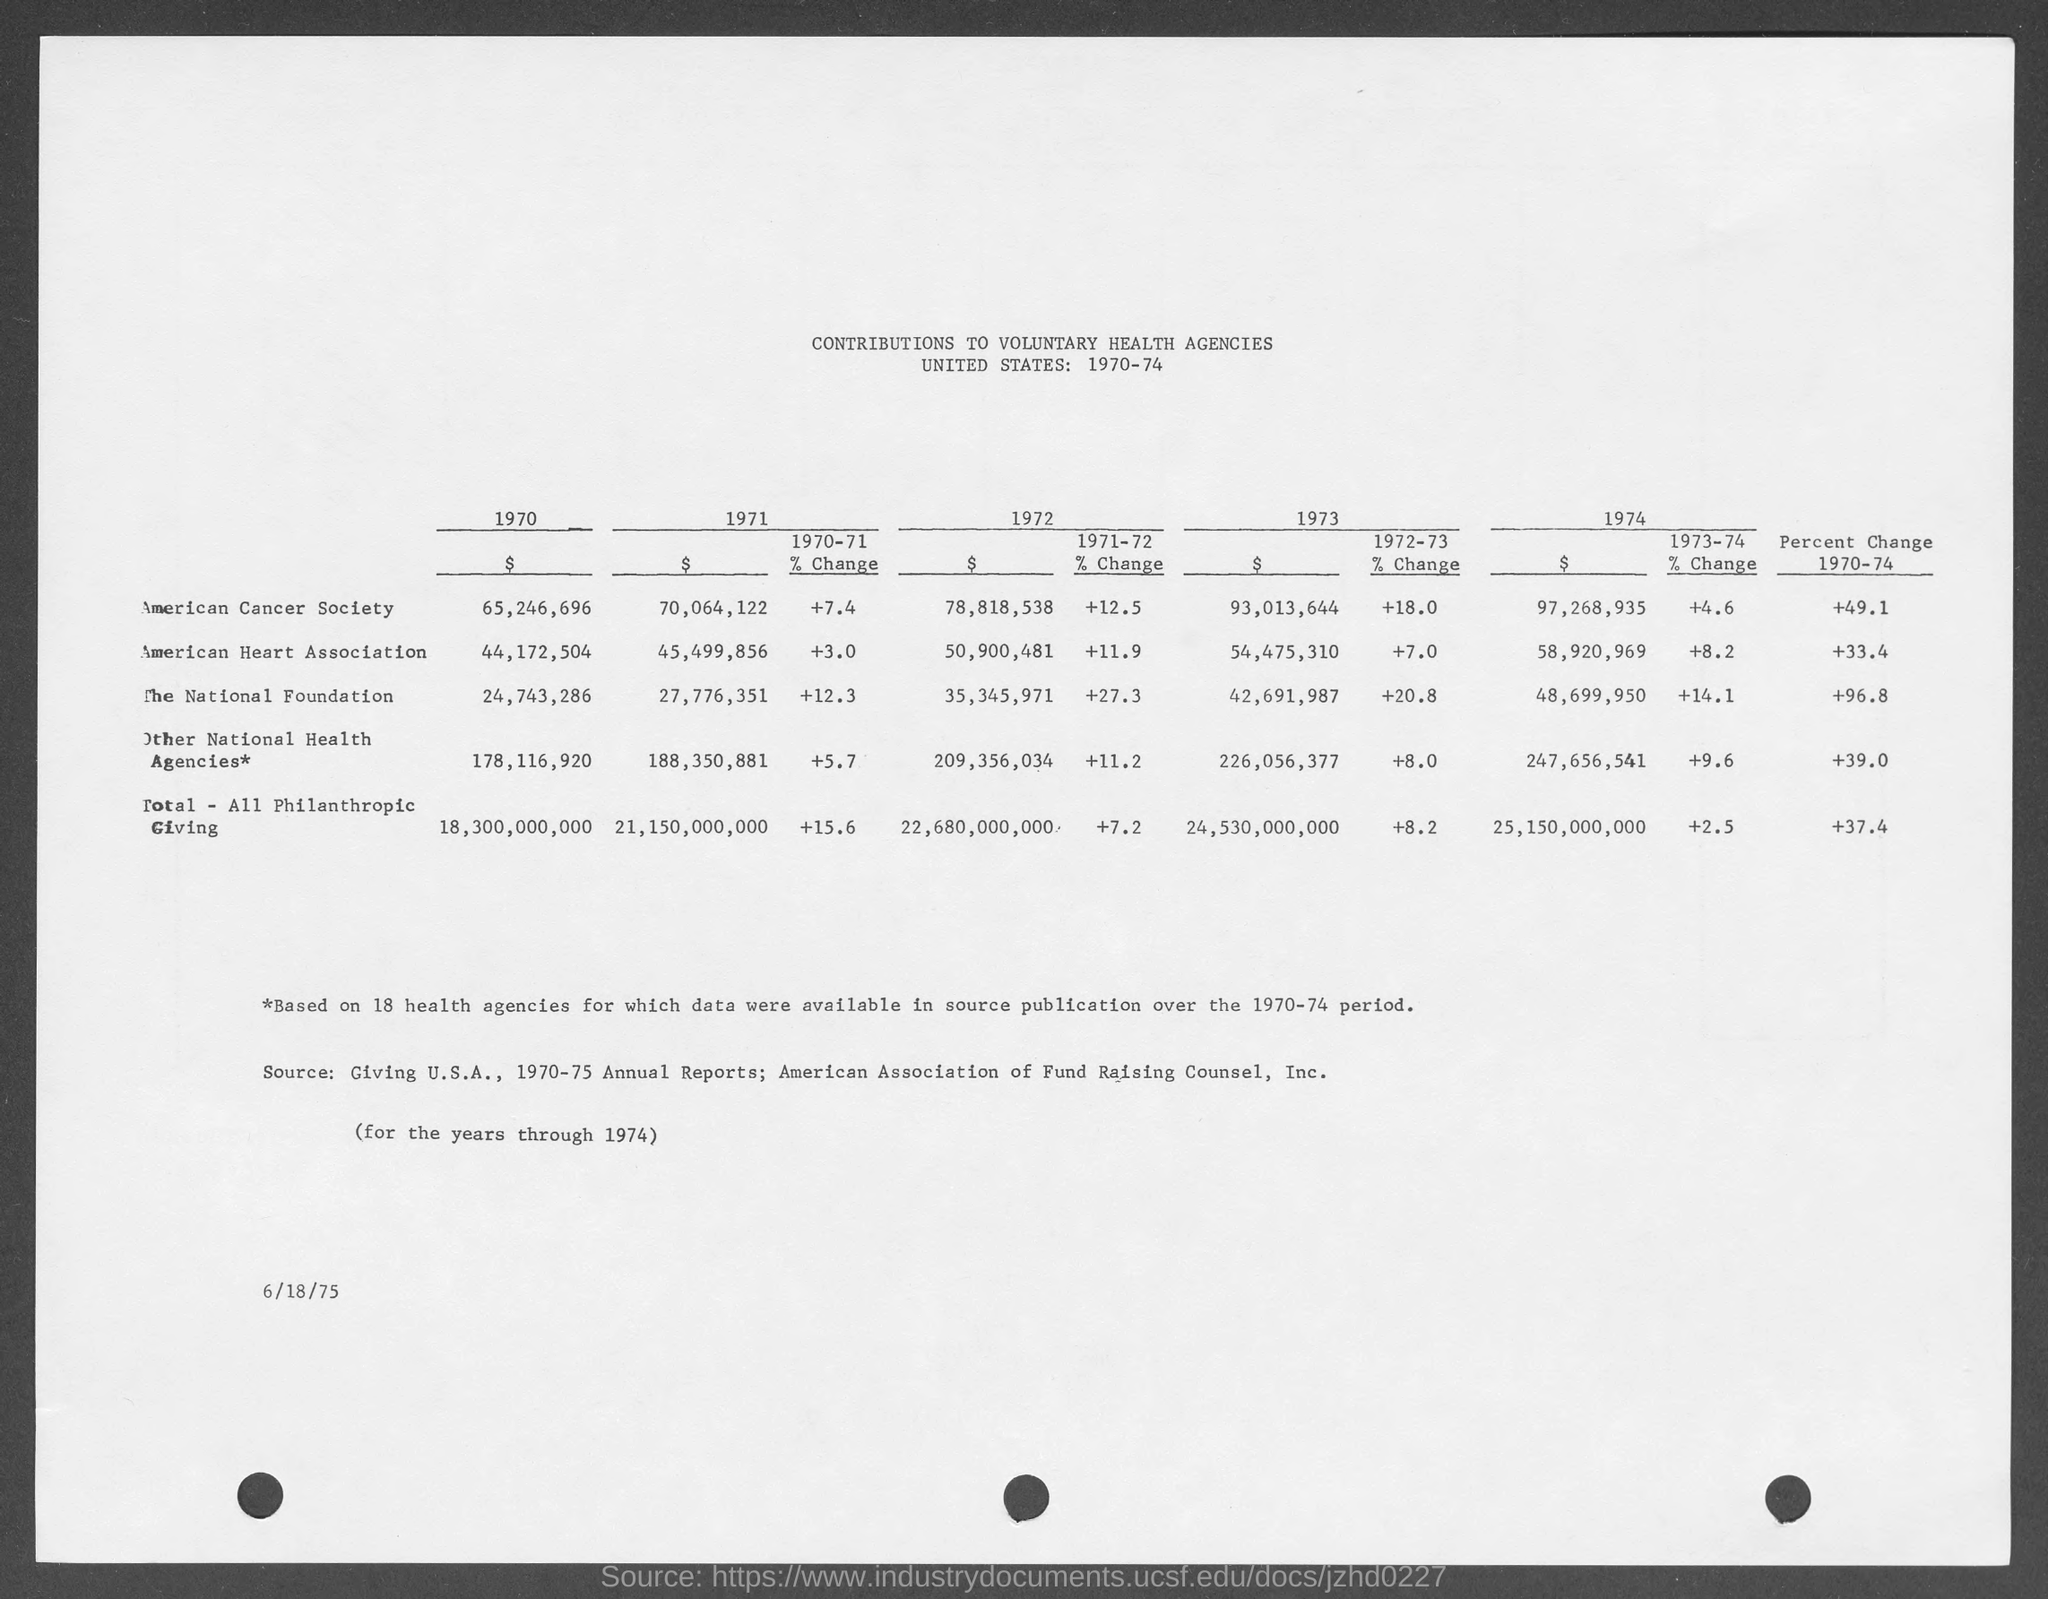What is the amount of the contribution given to the american cancer society in the year 1970 ?
Offer a very short reply. $ 65,246,696. What is the amount of contribution given to the american heart association in the year 1971 ?
Ensure brevity in your answer.  45,499,856. What is the amount of contribution given to the national foundation  in the year 1972?
Offer a very short reply. $ 35,345,971. What is the % change of the american cancer society during the year 1970-71 ?
Ensure brevity in your answer.  + 7.4. What is the amount of the contribution given to the american cancer society in the year 1971 ?
Make the answer very short. 70,064,122. What is the amount of the contribution given to american heart association in the year 1973 ?
Keep it short and to the point. $ 54,475,310. What is the amount of the % change in the national foundation during the year 1971-72 ?
Offer a very short reply. + 27.3. What is the amount of % change in the american cancer society during the year 1973-74 ?
Provide a succinct answer. + 4.6. What is the percent change in the american heart association from 1970-74 ?
Provide a short and direct response. +33.4. What is the amount of the contribution given to the national foundation in the year 1974 ?
Give a very brief answer. $ 48,699,950. 